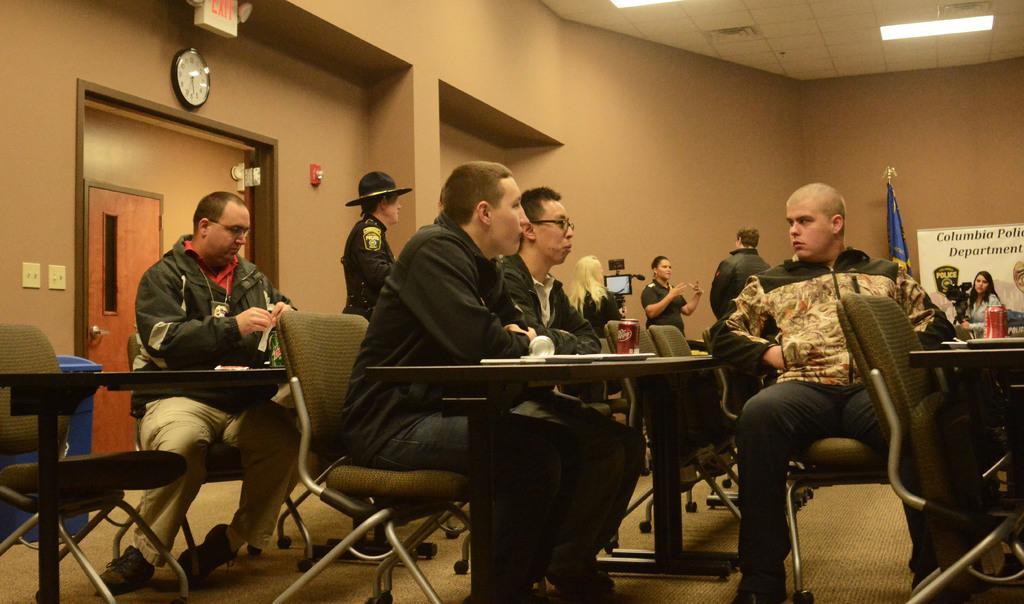Can you describe this image briefly? In the image we can see there are people who are sitting on chair and on table there are wine glass and cold drink can and at the back there is flag and on wall there is banner and few people are standing at the back and on wall there is clock. 